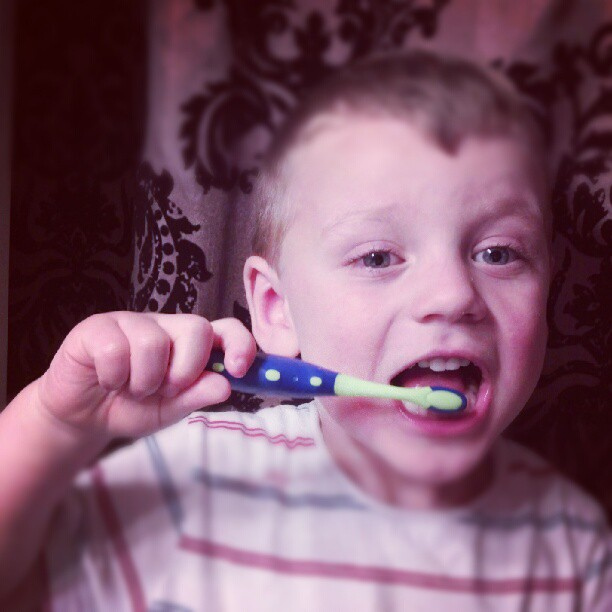<image>How many teeth does the boy have? It is impossible to determine the exact number of teeth the boy has. How many teeth does the boy have? It is unanswerable how many teeth the boy has. 